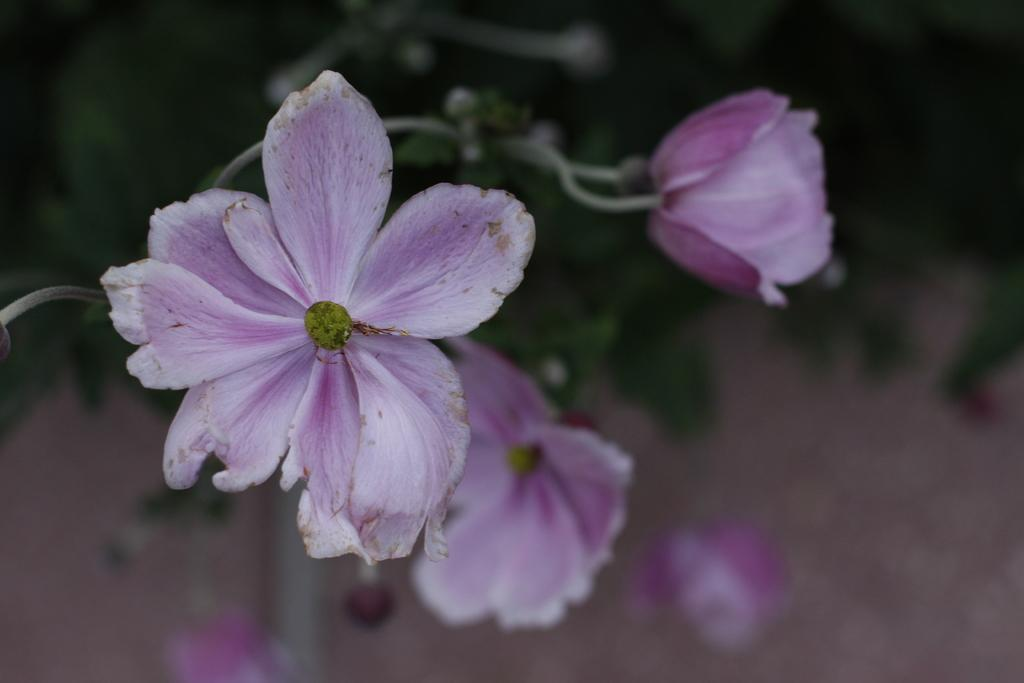What type of plants can be seen in the image? There are flowers in the image. What else can be seen in the background of the image? There are leaves in the background of the image. How would you describe the overall clarity of the image? The image is blurry. What type of zipper is visible on the flowers in the image? There is no zipper present in the image. The image features flowers and leaves in the background. 